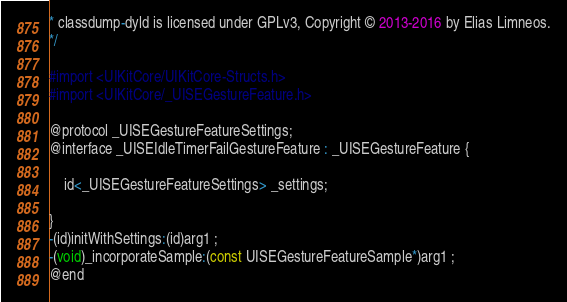<code> <loc_0><loc_0><loc_500><loc_500><_C_>* classdump-dyld is licensed under GPLv3, Copyright © 2013-2016 by Elias Limneos.
*/

#import <UIKitCore/UIKitCore-Structs.h>
#import <UIKitCore/_UISEGestureFeature.h>

@protocol _UISEGestureFeatureSettings;
@interface _UISEIdleTimerFailGestureFeature : _UISEGestureFeature {

	id<_UISEGestureFeatureSettings> _settings;

}
-(id)initWithSettings:(id)arg1 ;
-(void)_incorporateSample:(const UISEGestureFeatureSample*)arg1 ;
@end

</code> 